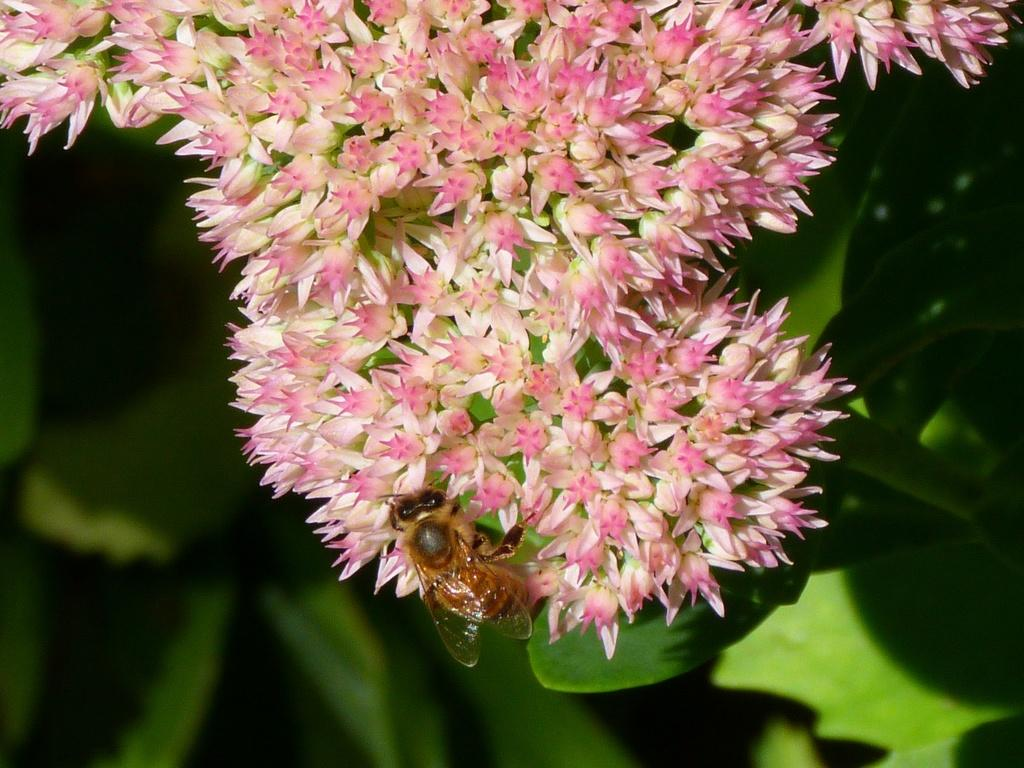What type of plant is in the image? There is a plant in the image, and it has flowers. Are there any signs of growth or development on the plant? Yes, there are buds on the plant. What is interacting with the plant in the image? A bee is present on the flowers of the plant. What can be seen in the background of the image? Leaves are visible in the background of the image. What is the condition of the alley in the image? There is no alley present in the image; it features a plant with flowers and a bee. Is there a bed visible in the image? No, there is no bed present in the image. 